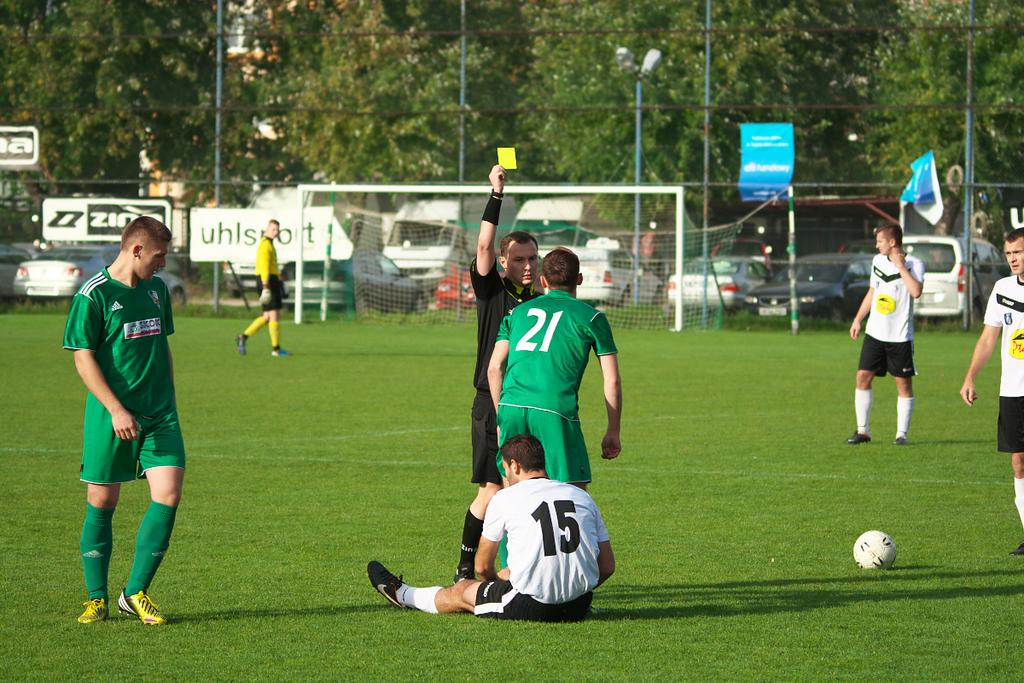<image>
Summarize the visual content of the image. Number 15 sits on the grass as number 21 gets a yellow card. 